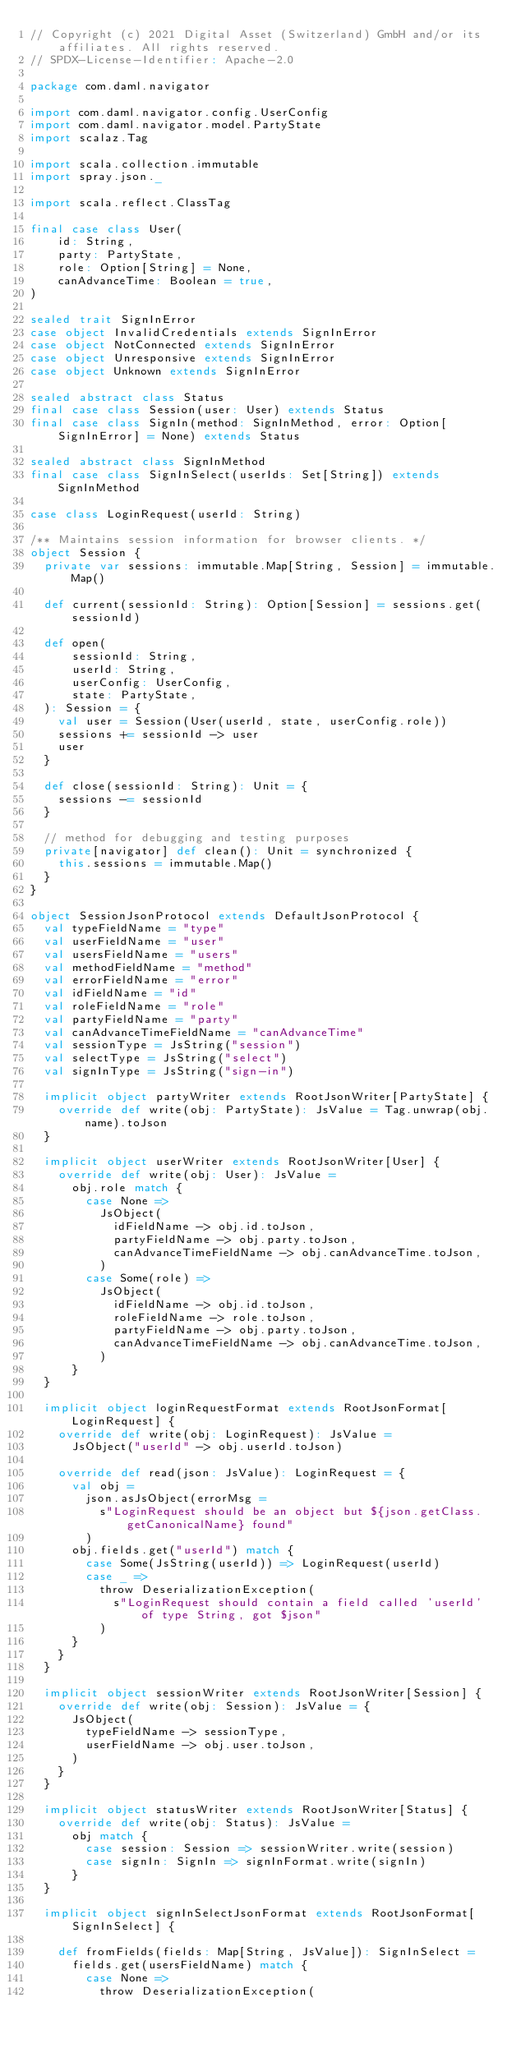Convert code to text. <code><loc_0><loc_0><loc_500><loc_500><_Scala_>// Copyright (c) 2021 Digital Asset (Switzerland) GmbH and/or its affiliates. All rights reserved.
// SPDX-License-Identifier: Apache-2.0

package com.daml.navigator

import com.daml.navigator.config.UserConfig
import com.daml.navigator.model.PartyState
import scalaz.Tag

import scala.collection.immutable
import spray.json._

import scala.reflect.ClassTag

final case class User(
    id: String,
    party: PartyState,
    role: Option[String] = None,
    canAdvanceTime: Boolean = true,
)

sealed trait SignInError
case object InvalidCredentials extends SignInError
case object NotConnected extends SignInError
case object Unresponsive extends SignInError
case object Unknown extends SignInError

sealed abstract class Status
final case class Session(user: User) extends Status
final case class SignIn(method: SignInMethod, error: Option[SignInError] = None) extends Status

sealed abstract class SignInMethod
final case class SignInSelect(userIds: Set[String]) extends SignInMethod

case class LoginRequest(userId: String)

/** Maintains session information for browser clients. */
object Session {
  private var sessions: immutable.Map[String, Session] = immutable.Map()

  def current(sessionId: String): Option[Session] = sessions.get(sessionId)

  def open(
      sessionId: String,
      userId: String,
      userConfig: UserConfig,
      state: PartyState,
  ): Session = {
    val user = Session(User(userId, state, userConfig.role))
    sessions += sessionId -> user
    user
  }

  def close(sessionId: String): Unit = {
    sessions -= sessionId
  }

  // method for debugging and testing purposes
  private[navigator] def clean(): Unit = synchronized {
    this.sessions = immutable.Map()
  }
}

object SessionJsonProtocol extends DefaultJsonProtocol {
  val typeFieldName = "type"
  val userFieldName = "user"
  val usersFieldName = "users"
  val methodFieldName = "method"
  val errorFieldName = "error"
  val idFieldName = "id"
  val roleFieldName = "role"
  val partyFieldName = "party"
  val canAdvanceTimeFieldName = "canAdvanceTime"
  val sessionType = JsString("session")
  val selectType = JsString("select")
  val signInType = JsString("sign-in")

  implicit object partyWriter extends RootJsonWriter[PartyState] {
    override def write(obj: PartyState): JsValue = Tag.unwrap(obj.name).toJson
  }

  implicit object userWriter extends RootJsonWriter[User] {
    override def write(obj: User): JsValue =
      obj.role match {
        case None =>
          JsObject(
            idFieldName -> obj.id.toJson,
            partyFieldName -> obj.party.toJson,
            canAdvanceTimeFieldName -> obj.canAdvanceTime.toJson,
          )
        case Some(role) =>
          JsObject(
            idFieldName -> obj.id.toJson,
            roleFieldName -> role.toJson,
            partyFieldName -> obj.party.toJson,
            canAdvanceTimeFieldName -> obj.canAdvanceTime.toJson,
          )
      }
  }

  implicit object loginRequestFormat extends RootJsonFormat[LoginRequest] {
    override def write(obj: LoginRequest): JsValue =
      JsObject("userId" -> obj.userId.toJson)

    override def read(json: JsValue): LoginRequest = {
      val obj =
        json.asJsObject(errorMsg =
          s"LoginRequest should be an object but ${json.getClass.getCanonicalName} found"
        )
      obj.fields.get("userId") match {
        case Some(JsString(userId)) => LoginRequest(userId)
        case _ =>
          throw DeserializationException(
            s"LoginRequest should contain a field called 'userId' of type String, got $json"
          )
      }
    }
  }

  implicit object sessionWriter extends RootJsonWriter[Session] {
    override def write(obj: Session): JsValue = {
      JsObject(
        typeFieldName -> sessionType,
        userFieldName -> obj.user.toJson,
      )
    }
  }

  implicit object statusWriter extends RootJsonWriter[Status] {
    override def write(obj: Status): JsValue =
      obj match {
        case session: Session => sessionWriter.write(session)
        case signIn: SignIn => signInFormat.write(signIn)
      }
  }

  implicit object signInSelectJsonFormat extends RootJsonFormat[SignInSelect] {

    def fromFields(fields: Map[String, JsValue]): SignInSelect =
      fields.get(usersFieldName) match {
        case None =>
          throw DeserializationException(</code> 